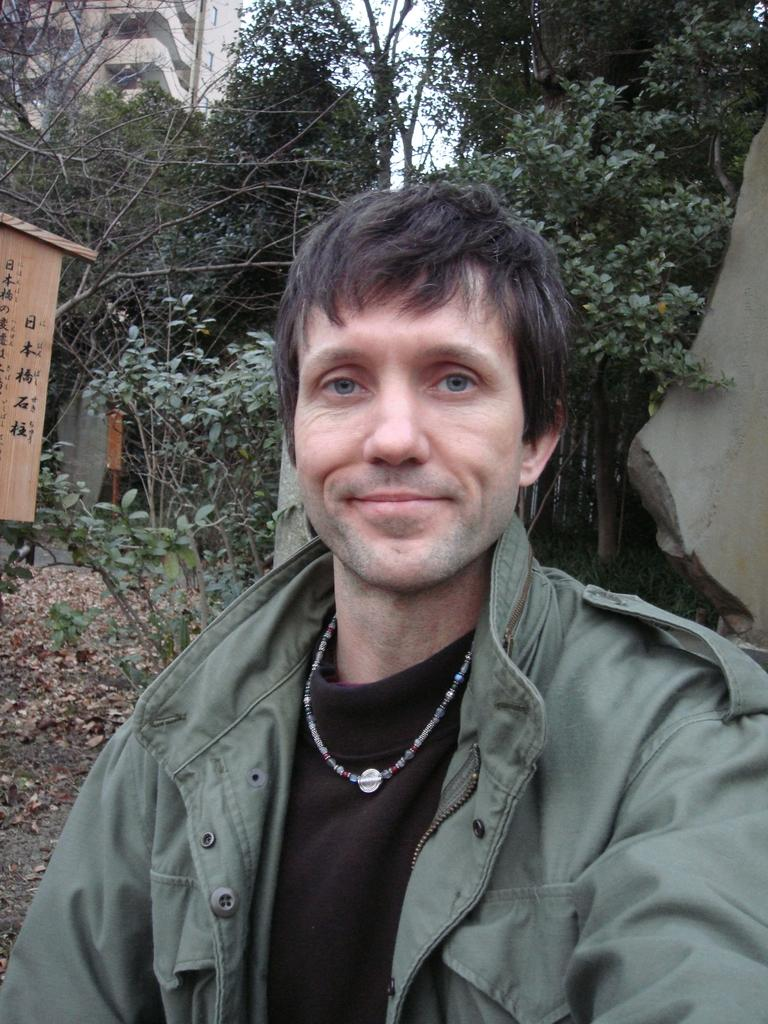What is present in the image? There is a person in the image. Can you describe the person's attire? The person is wearing a black and green colored dress. What can be seen in the background of the image? There are trees, buildings, and other objects in the background of the image. What is the person's tendency to use a spoon in the image? There is no spoon present in the image, so it is not possible to determine the person's tendency to use one. 